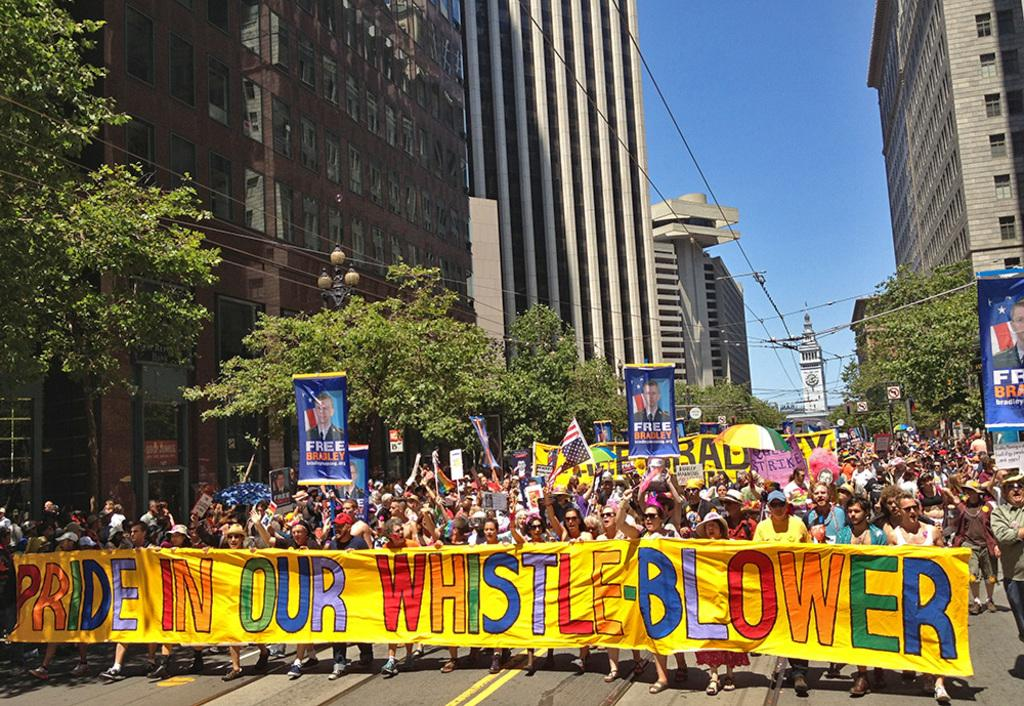What are the people in the image doing? People are protesting on the road. What items are being used during the protest? Flags, posters, and banners are being used during the protest. What can be seen on either side of the road? Trees, buildings, and electrical wires are visible on either side of the road. How many giants can be seen participating in the protest? There are no giants present in the image; it features people protesting on the road. Is there a stream visible in the image? There is no stream present in the image. 